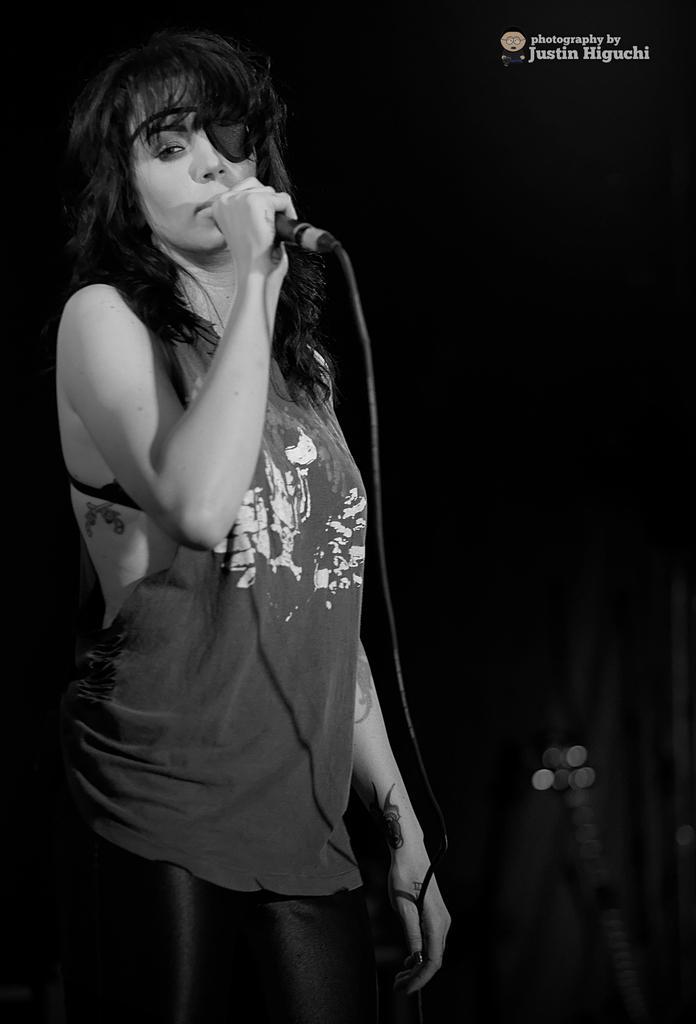Please provide a concise description of this image. In this image I can see a woman standing and holding a mic in her hand. 